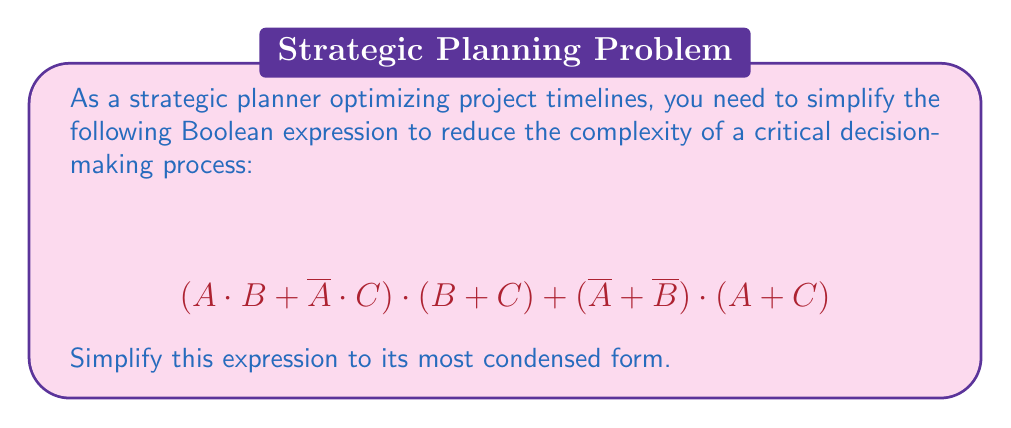Can you solve this math problem? Let's simplify this Boolean expression step-by-step:

1) First, let's apply the distributive law to the first term:
   $$(A \cdot B + \overline{A} \cdot C) \cdot (B + C) = A \cdot B \cdot B + A \cdot B \cdot C + \overline{A} \cdot C \cdot B + \overline{A} \cdot C \cdot C$$

2) Simplify using the idempotent law ($X \cdot X = X$):
   $$A \cdot B + A \cdot B \cdot C + \overline{A} \cdot C \cdot B + \overline{A} \cdot C$$

3) Now, let's simplify the second term $(\overline{A} + \overline{B}) \cdot (A + C)$:
   $$\overline{A} \cdot A + \overline{A} \cdot C + \overline{B} \cdot A + \overline{B} \cdot C$$

4) $\overline{A} \cdot A = 0$, so we can remove that term:
   $$\overline{A} \cdot C + \overline{B} \cdot A + \overline{B} \cdot C$$

5) Now, let's combine all terms from steps 2 and 4:
   $$A \cdot B + A \cdot B \cdot C + \overline{A} \cdot C \cdot B + \overline{A} \cdot C + \overline{A} \cdot C + \overline{B} \cdot A + \overline{B} \cdot C$$

6) Simplify by combining like terms:
   $$A \cdot B + A \cdot B \cdot C + \overline{A} \cdot C \cdot B + \overline{A} \cdot C + \overline{B} \cdot A + \overline{B} \cdot C$$

7) $A \cdot B + A \cdot B \cdot C$ can be simplified to $A \cdot B$ (absorption law):
   $$A \cdot B + \overline{A} \cdot C \cdot B + \overline{A} \cdot C + \overline{B} \cdot A + \overline{B} \cdot C$$

8) $\overline{A} \cdot C \cdot B + \overline{A} \cdot C$ can be simplified to $\overline{A} \cdot C$ (absorption law):
   $$A \cdot B + \overline{A} \cdot C + \overline{B} \cdot A + \overline{B} \cdot C$$

9) This is the most simplified form we can achieve without further information about the relationships between A, B, and C.
Answer: $$A \cdot B + \overline{A} \cdot C + \overline{B} \cdot A + \overline{B} \cdot C$$ 